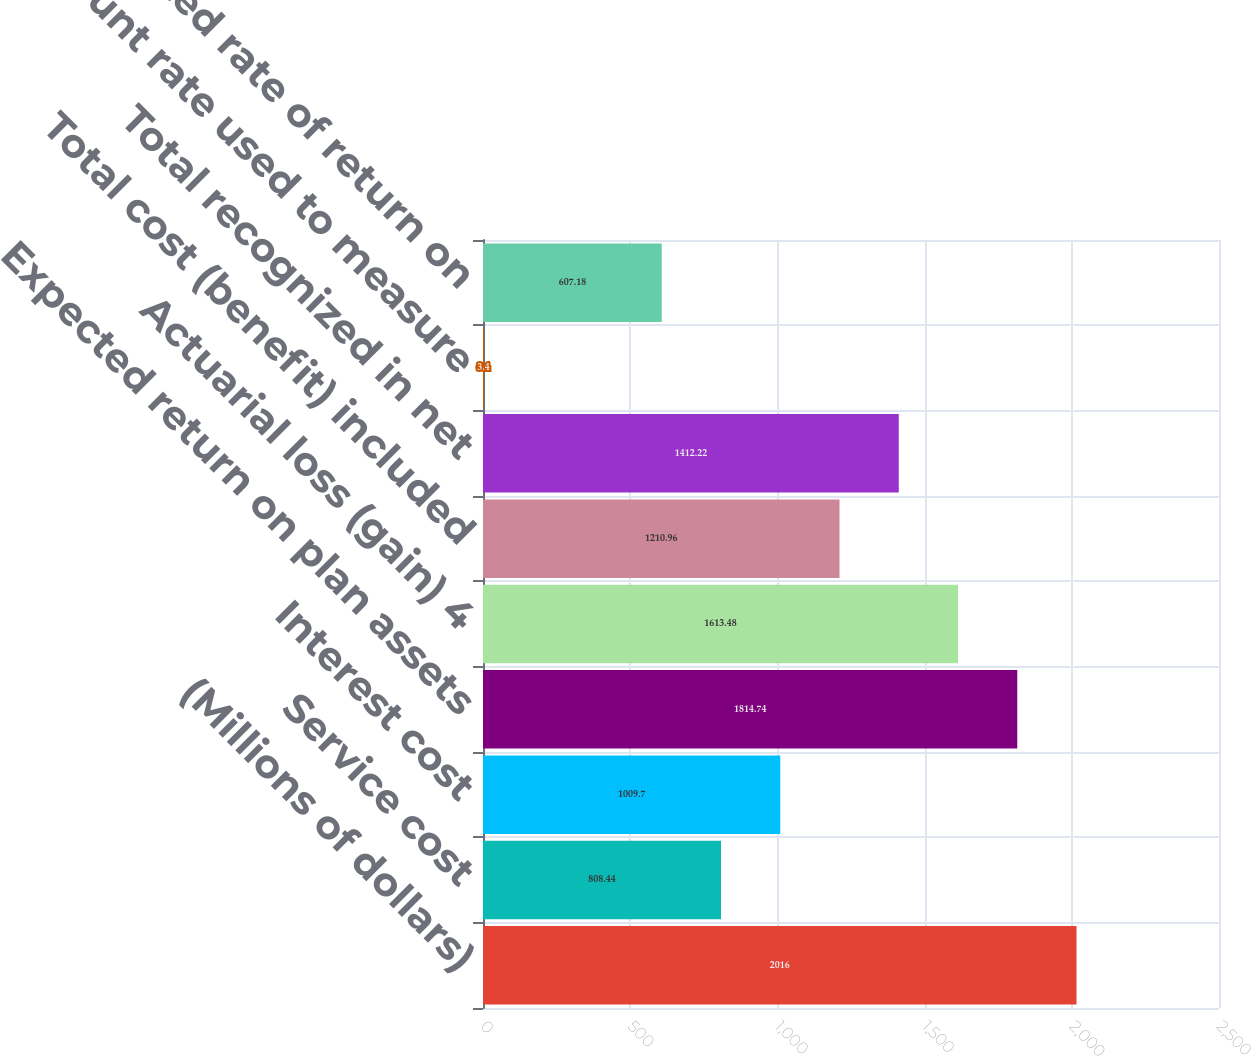Convert chart to OTSL. <chart><loc_0><loc_0><loc_500><loc_500><bar_chart><fcel>(Millions of dollars)<fcel>Service cost<fcel>Interest cost<fcel>Expected return on plan assets<fcel>Actuarial loss (gain) 4<fcel>Total cost (benefit) included<fcel>Total recognized in net<fcel>Discount rate used to measure<fcel>Expected rate of return on<nl><fcel>2016<fcel>808.44<fcel>1009.7<fcel>1814.74<fcel>1613.48<fcel>1210.96<fcel>1412.22<fcel>3.4<fcel>607.18<nl></chart> 